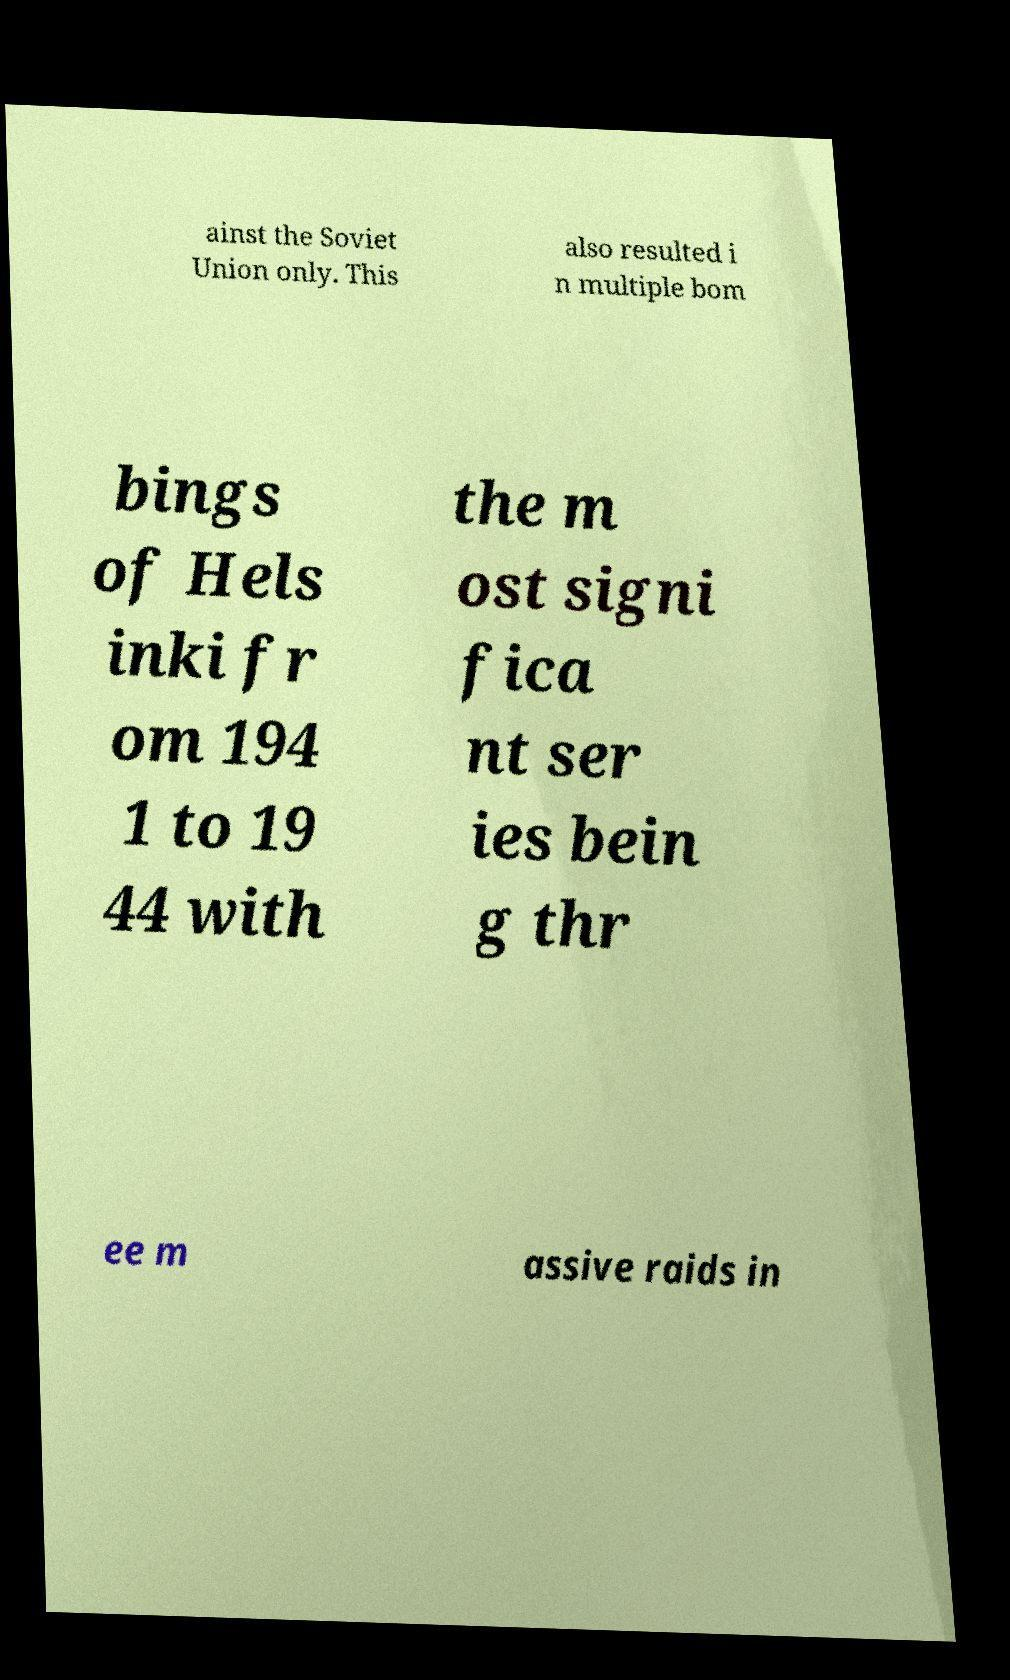For documentation purposes, I need the text within this image transcribed. Could you provide that? ainst the Soviet Union only. This also resulted i n multiple bom bings of Hels inki fr om 194 1 to 19 44 with the m ost signi fica nt ser ies bein g thr ee m assive raids in 